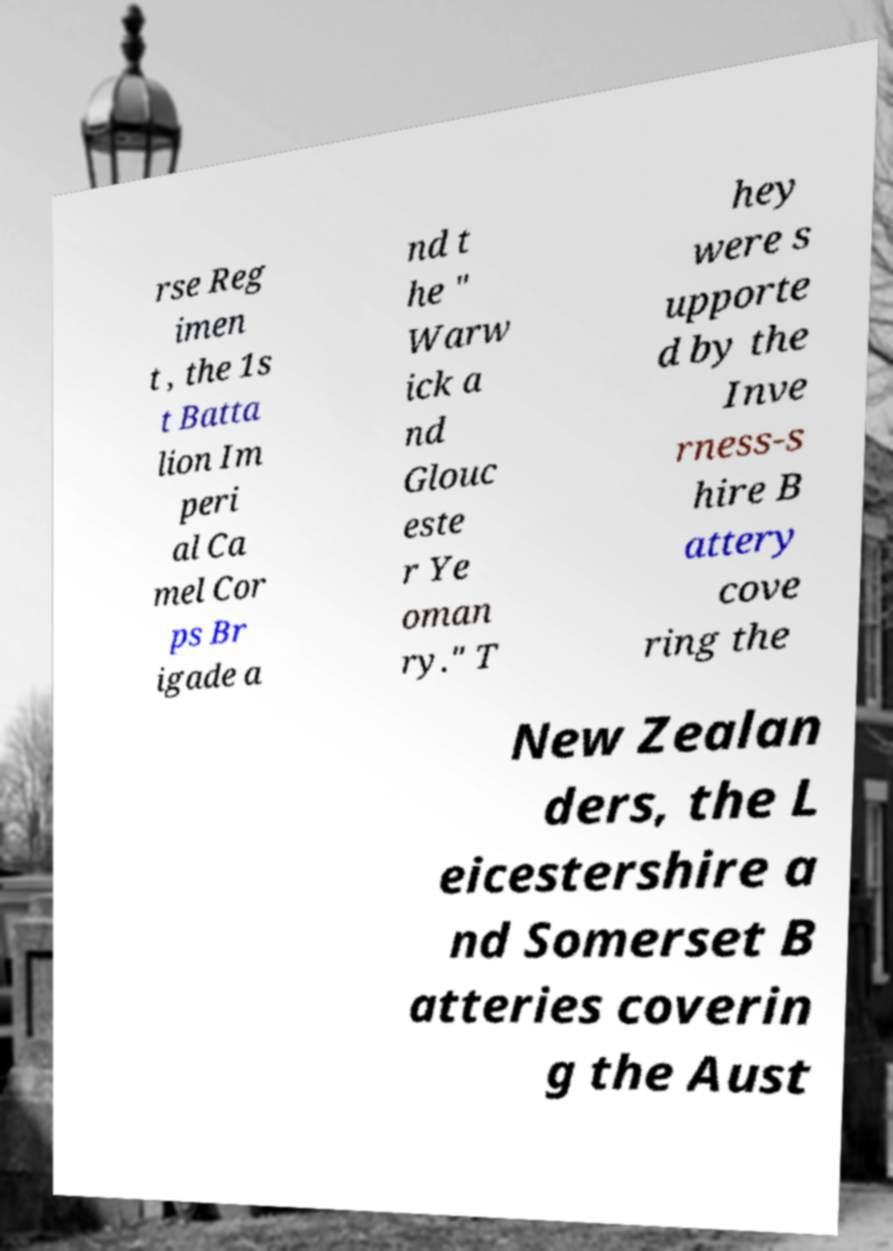There's text embedded in this image that I need extracted. Can you transcribe it verbatim? rse Reg imen t , the 1s t Batta lion Im peri al Ca mel Cor ps Br igade a nd t he " Warw ick a nd Glouc este r Ye oman ry." T hey were s upporte d by the Inve rness-s hire B attery cove ring the New Zealan ders, the L eicestershire a nd Somerset B atteries coverin g the Aust 